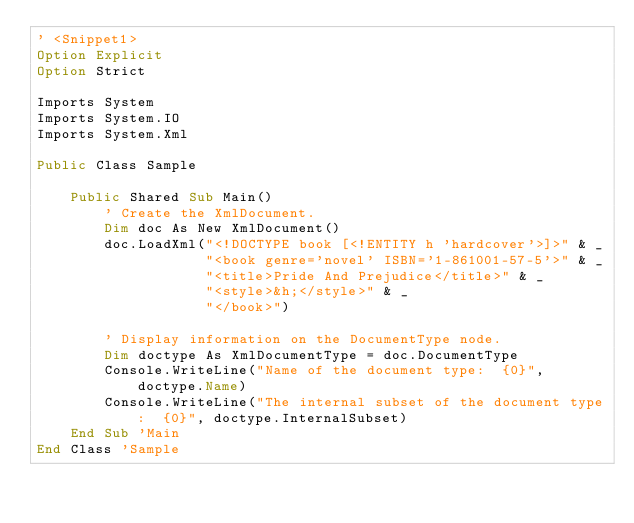<code> <loc_0><loc_0><loc_500><loc_500><_VisualBasic_>' <Snippet1>
Option Explicit
Option Strict

Imports System
Imports System.IO
Imports System.Xml

Public Class Sample
    
    Public Shared Sub Main()
        ' Create the XmlDocument.
        Dim doc As New XmlDocument()
        doc.LoadXml("<!DOCTYPE book [<!ENTITY h 'hardcover'>]>" & _
                    "<book genre='novel' ISBN='1-861001-57-5'>" & _
                    "<title>Pride And Prejudice</title>" & _
                    "<style>&h;</style>" & _
                    "</book>")
        
        ' Display information on the DocumentType node.
        Dim doctype As XmlDocumentType = doc.DocumentType
        Console.WriteLine("Name of the document type:  {0}", doctype.Name)
        Console.WriteLine("The internal subset of the document type:  {0}", doctype.InternalSubset)
    End Sub 'Main 
End Class 'Sample</code> 